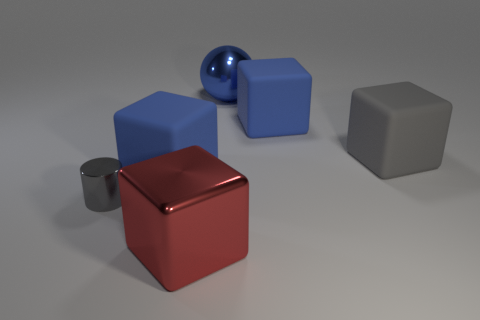Are there any matte things?
Ensure brevity in your answer.  Yes. Is there anything else that has the same color as the shiny cylinder?
Provide a succinct answer. Yes. There is a tiny thing that is made of the same material as the large sphere; what shape is it?
Make the answer very short. Cylinder. What color is the big shiny cube that is to the left of the object on the right side of the big blue matte cube on the right side of the big red shiny cube?
Offer a terse response. Red. Is the number of blue shiny balls that are left of the red shiny cube the same as the number of gray cylinders?
Offer a terse response. No. There is a big metal cube; does it have the same color as the big shiny thing on the right side of the red metallic block?
Offer a very short reply. No. There is a blue matte object on the left side of the blue rubber object that is to the right of the blue sphere; is there a blue shiny sphere that is to the left of it?
Your answer should be compact. No. Is the number of small objects that are in front of the tiny gray metallic cylinder less than the number of big red blocks?
Offer a terse response. Yes. What number of other objects are the same shape as the blue metallic object?
Offer a very short reply. 0. How many objects are large matte things left of the red metallic cube or blue rubber blocks that are to the left of the red metal block?
Provide a short and direct response. 1. 